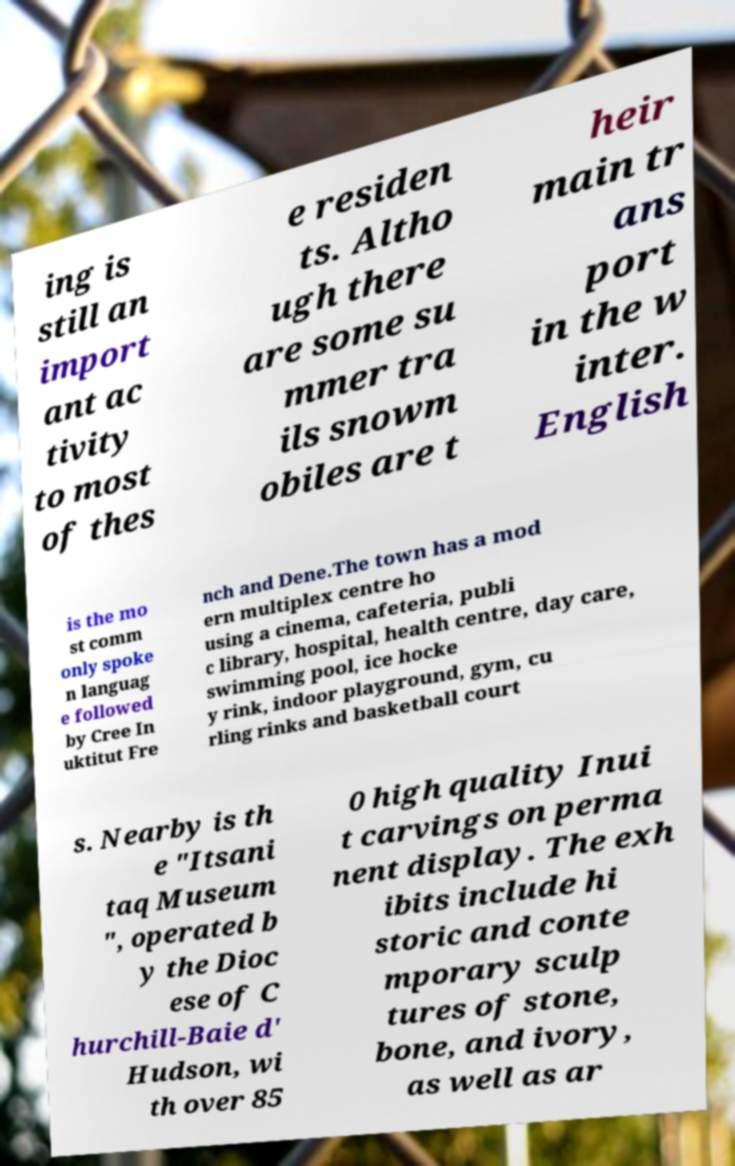I need the written content from this picture converted into text. Can you do that? ing is still an import ant ac tivity to most of thes e residen ts. Altho ugh there are some su mmer tra ils snowm obiles are t heir main tr ans port in the w inter. English is the mo st comm only spoke n languag e followed by Cree In uktitut Fre nch and Dene.The town has a mod ern multiplex centre ho using a cinema, cafeteria, publi c library, hospital, health centre, day care, swimming pool, ice hocke y rink, indoor playground, gym, cu rling rinks and basketball court s. Nearby is th e "Itsani taq Museum ", operated b y the Dioc ese of C hurchill-Baie d' Hudson, wi th over 85 0 high quality Inui t carvings on perma nent display. The exh ibits include hi storic and conte mporary sculp tures of stone, bone, and ivory, as well as ar 